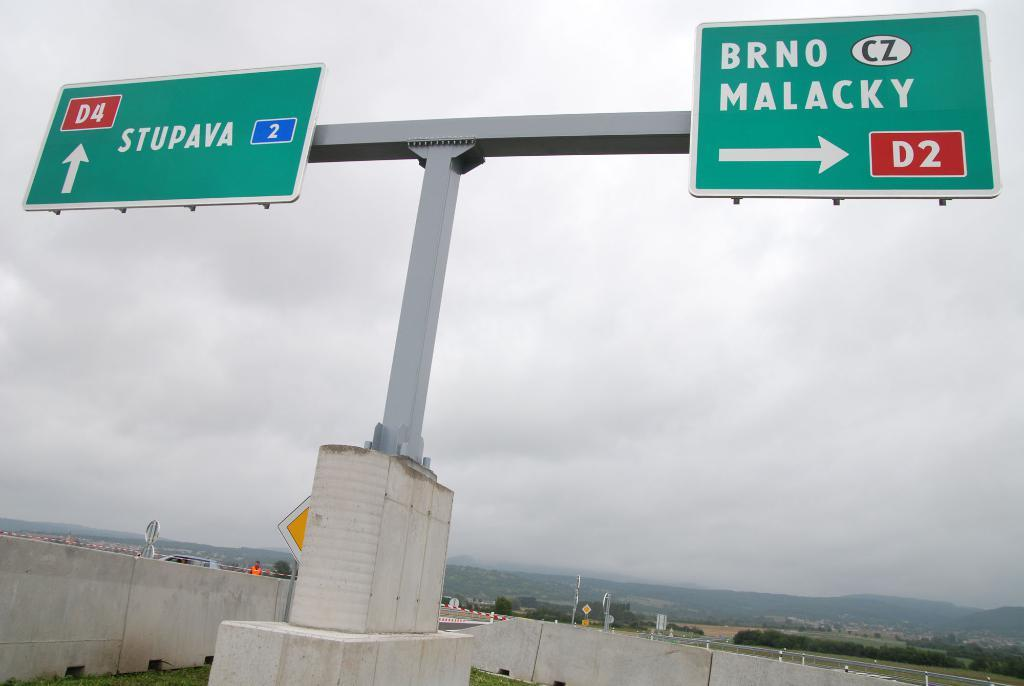<image>
Describe the image concisely. A road sign indicates that drivers need to go right to get to BRNO MALACKY. 